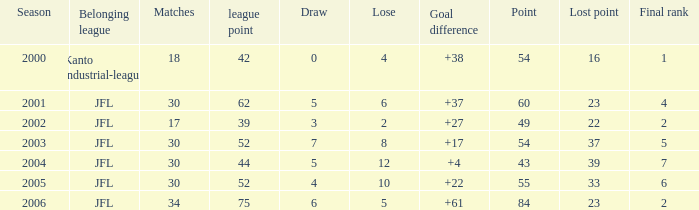With 33 points lost and league points under 52, what is the highest possible point? None. 